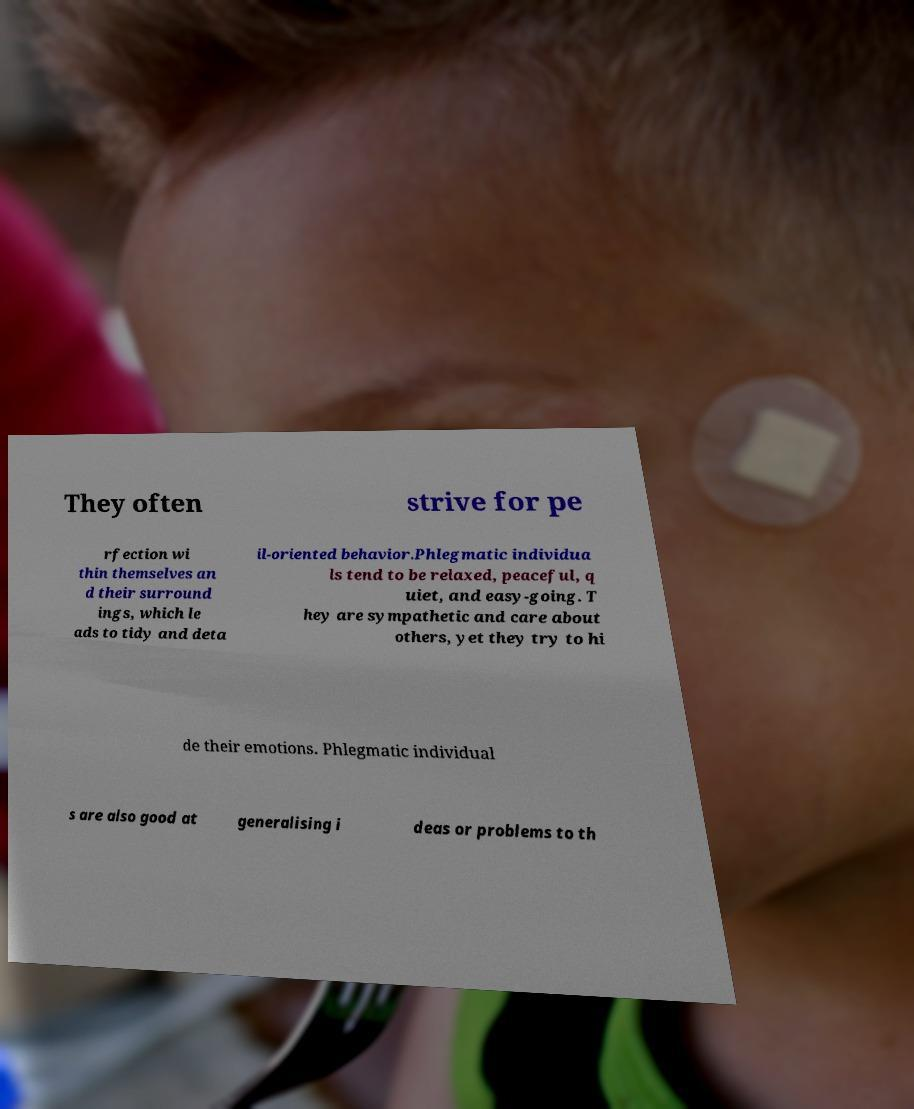I need the written content from this picture converted into text. Can you do that? They often strive for pe rfection wi thin themselves an d their surround ings, which le ads to tidy and deta il-oriented behavior.Phlegmatic individua ls tend to be relaxed, peaceful, q uiet, and easy-going. T hey are sympathetic and care about others, yet they try to hi de their emotions. Phlegmatic individual s are also good at generalising i deas or problems to th 